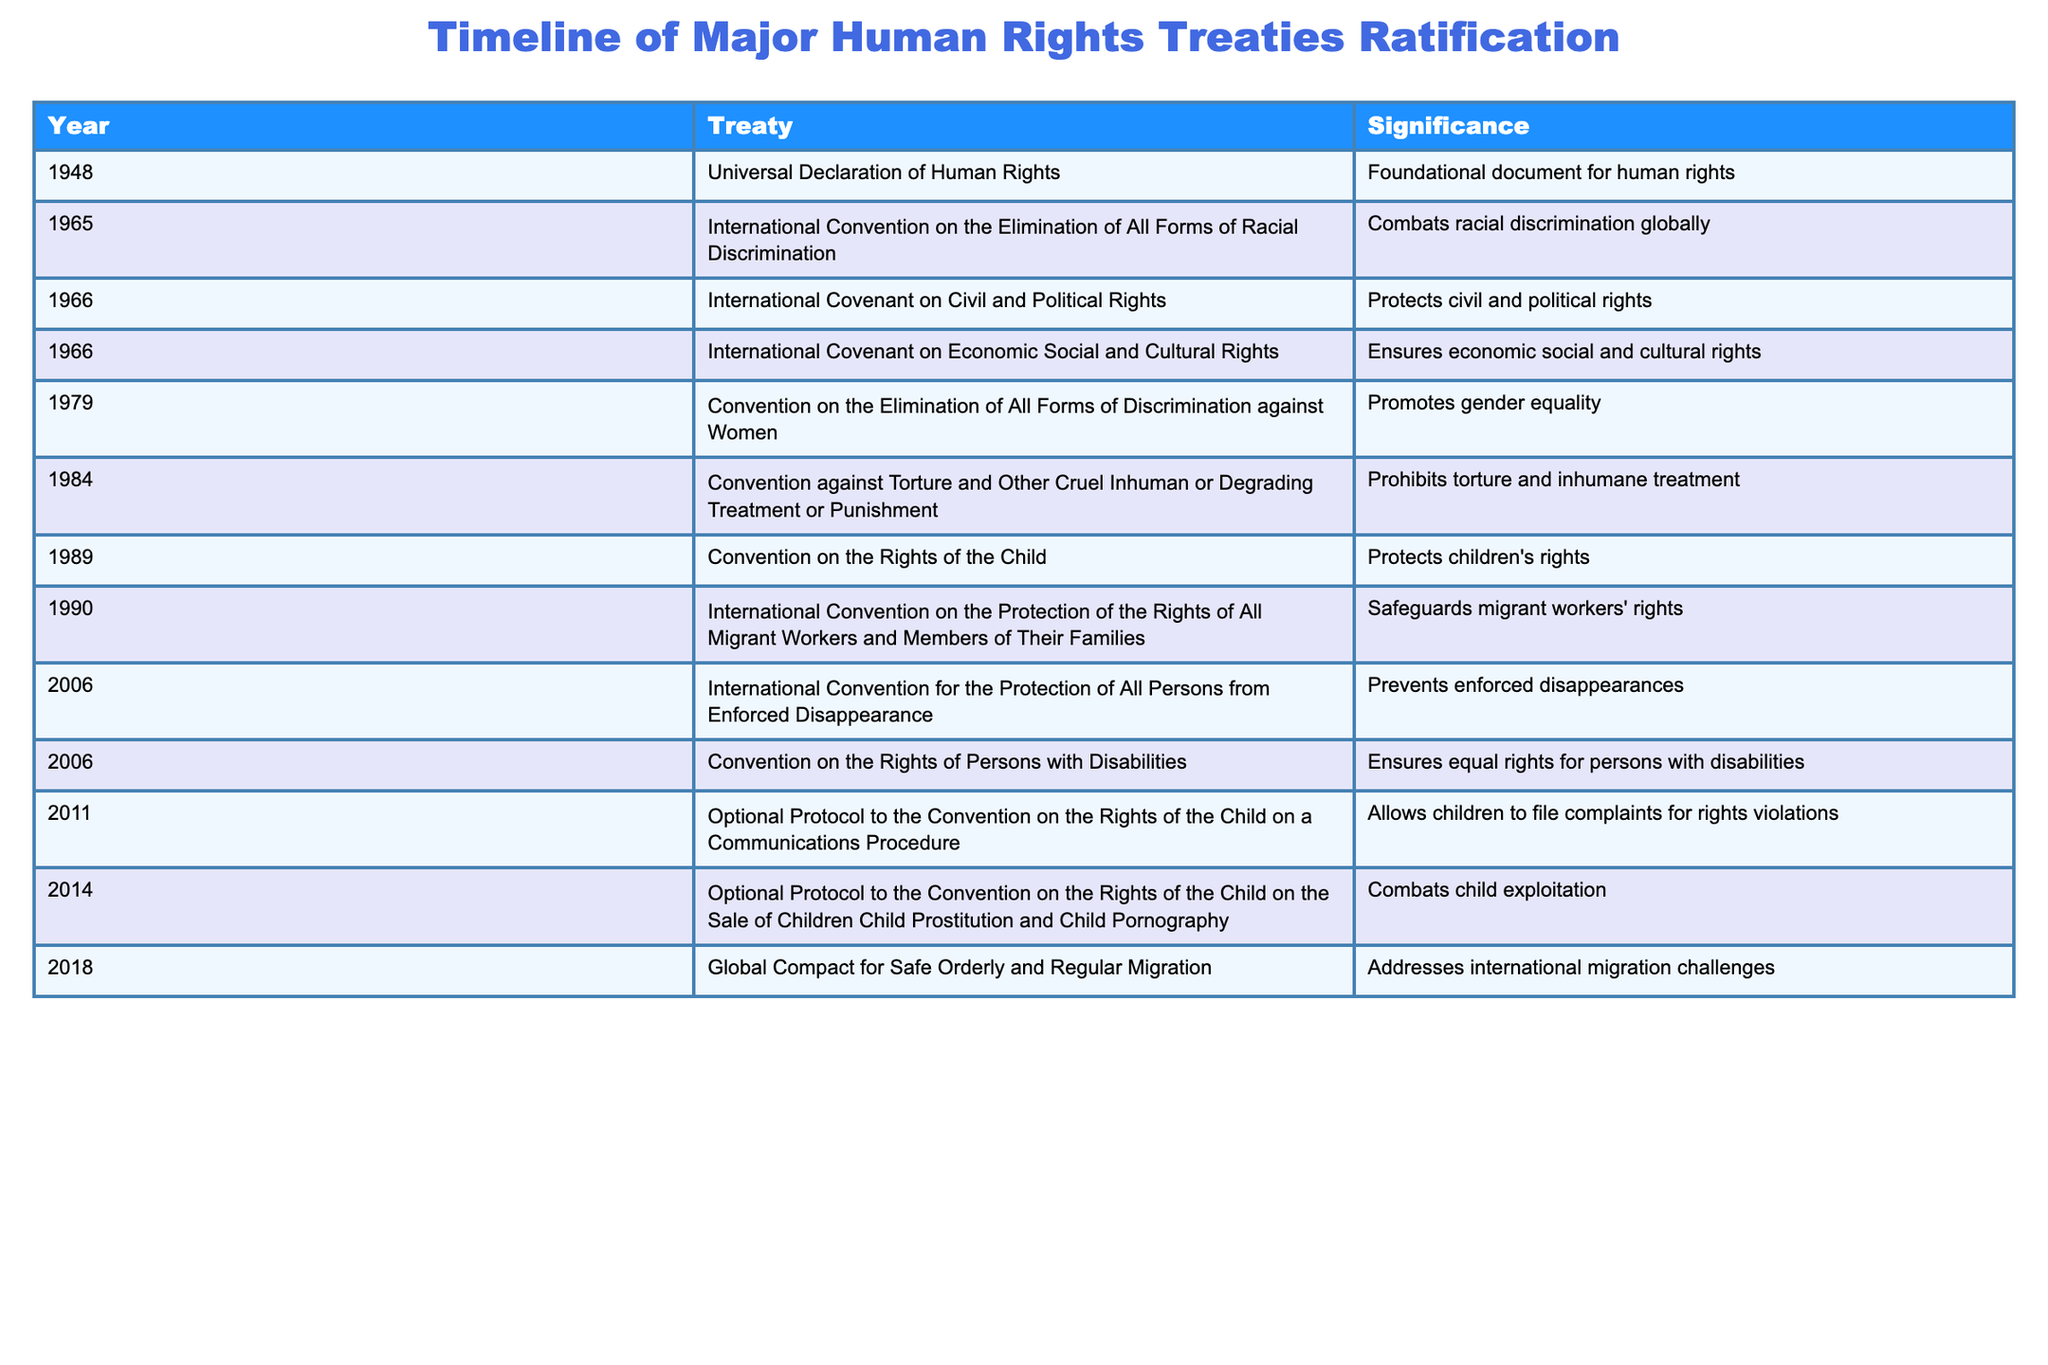What is the significance of the Universal Declaration of Human Rights? According to the table, the Universal Declaration of Human Rights was ratified in 1948 and is described as the foundational document for human rights.
Answer: Foundational document for human rights How many treaties were ratified in the 2000s? The treaties ratified in the 2000s are listed as two: the International Convention for the Protection of All Persons from Enforced Disappearance in 2006 and the Convention on the Rights of Persons with Disabilities in 2006, thus totaling two treaties.
Answer: 2 Did the Convention on the Rights of the Child protect rights for children? The table indicates that the Convention on the Rights of the Child was ratified in 1989 and describes its significance as protecting children's rights. Thus, the answer is yes.
Answer: Yes Which treaty was ratified to combat child exploitation? The table shows that the Optional Protocol to the Convention on the Rights of the Child on the Sale of Children, Child Prostitution, and Child Pornography was ratified in 2014 specifically to combat child exploitation.
Answer: Optional Protocol to the Convention on the Rights of the Child on the Sale of Children, Child Prostitution, and Child Pornography What is the total number of treaties that address discrimination against specific groups? The treaties addressing discrimination are the International Convention on the Elimination of All Forms of Racial Discrimination (1965), the Convention on the Elimination of All Forms of Discrimination against Women (1979), and the Convention on the Rights of Persons with Disabilities (2006). This adds up to three treaties.
Answer: 3 